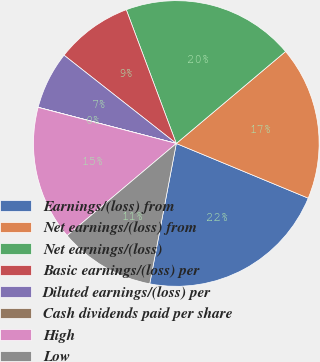Convert chart to OTSL. <chart><loc_0><loc_0><loc_500><loc_500><pie_chart><fcel>Earnings/(loss) from<fcel>Net earnings/(loss) from<fcel>Net earnings/(loss)<fcel>Basic earnings/(loss) per<fcel>Diluted earnings/(loss) per<fcel>Cash dividends paid per share<fcel>High<fcel>Low<nl><fcel>21.73%<fcel>17.39%<fcel>19.56%<fcel>8.7%<fcel>6.53%<fcel>0.01%<fcel>15.22%<fcel>10.87%<nl></chart> 